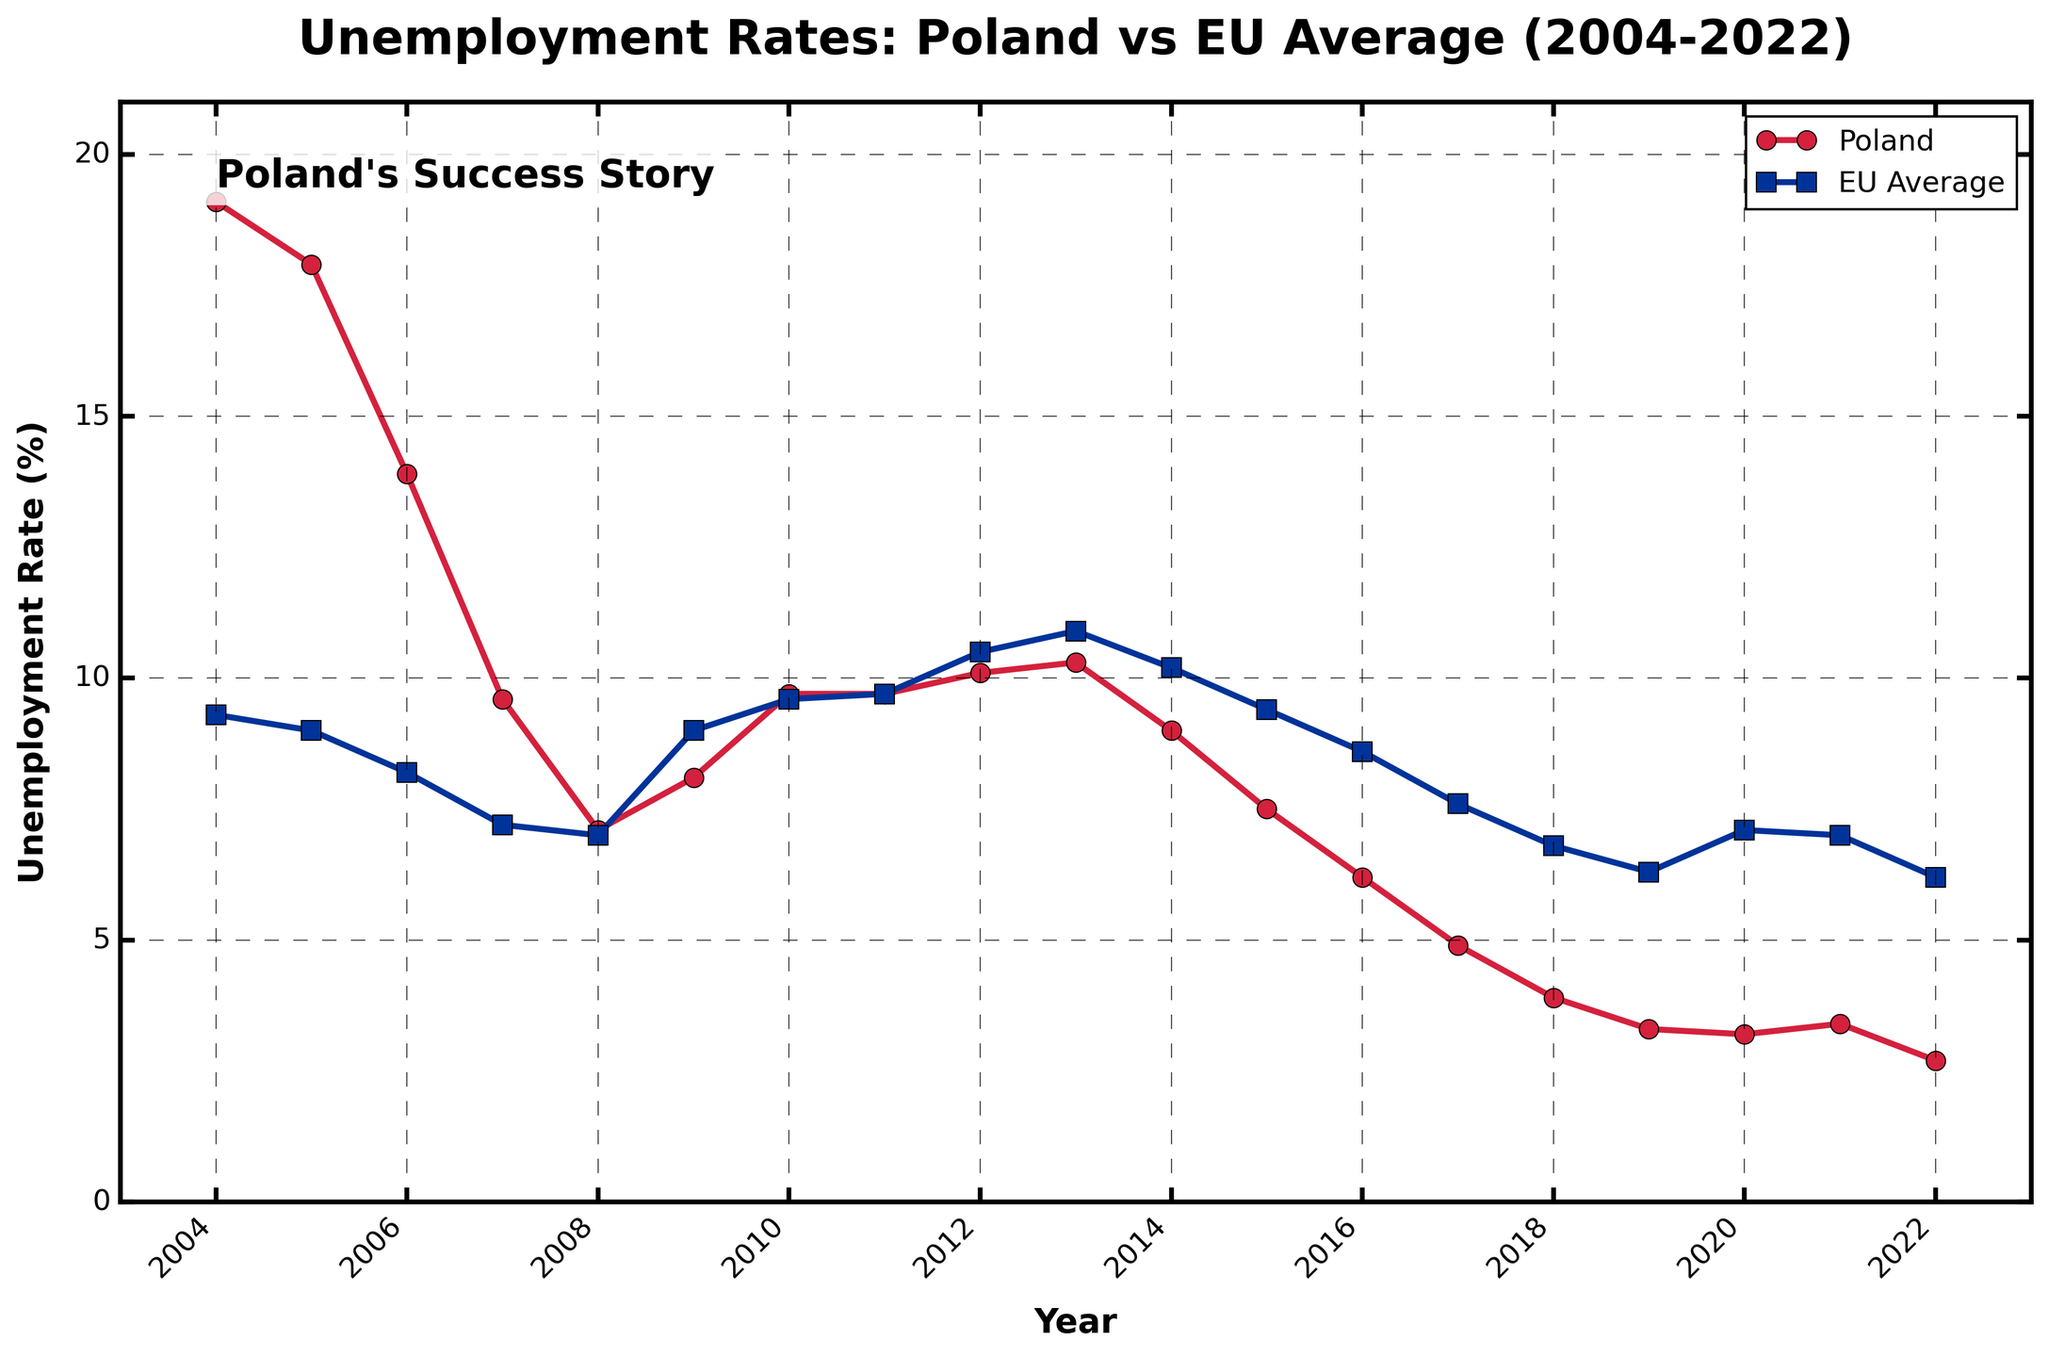What were the highest and lowest unemployment rates in Poland from 2004 to 2022? The highest unemployment rate in Poland occurred in 2004 at 19.1%, and the lowest rate was in 2022 at 2.7%. These can be identified by observing the peaks and troughs on the Poland line in the chart.
Answer: Highest: 19.1%, Lowest: 2.7% Between which years did Poland's unemployment rate fall below the EU average for the first time? The Poland unemployment rate first fell below the EU average between 2008 and 2009 when Poland's rate was 7.1% and the EU rate was 7.0%. By 2009, Poland's rate increased slightly but was more than the EU average again.
Answer: 2008 How did the unemployment rate in Poland change from 2004 to 2008, and how did it compare to the EU average in 2008? In 2004, Poland had an unemployment rate of 19.1%, which rapidly decreased to 7.1% by 2008. The EU average, on the other hand, decreased slightly from 9.3% to 7.0%. So, in 2008, Poland was just higher than the EU average.
Answer: Decreased to 7.1%; EU average at 7.0% Which year had the largest gap between the Poland unemployment rate and the EU average, and what was the gap? The largest gap occurred in 2004, with Poland at 19.1% and the EU average at 9.3%. This results in a gap of 19.1% - 9.3% = 9.8%.
Answer: 2004, 9.8% Between 2012 and 2017, did Poland's unemployment rate ever exceed the EU average? No, Poland's unemployment rate did not exceed the EU average between 2012 and 2017. During this period, Poland's rate consistently stayed lower than the EU average.
Answer: No From 2011 to 2013, how did the trend of unemployment rates compare between Poland and the EU average? Between 2011 and 2013, Poland’s unemployment rate increased from 9.7% to 10.3%. The EU average also increased from 9.7% to 10.9%. Thus, both showed an increasing trend during this period.
Answer: Both increased What can be inferred about the trends in Poland’s unemployment rate after it joined the EU compared to the EU average? After joining the EU, Poland's unemployment rate showed a generally steep downward trend, especially between 2004 to 2008, and consistently fell below the EU average after 2013. The EU average fluctuated but declined more moderately.
Answer: Poland decreased steeply, EU average fluctuated In which year did Poland have the lowest unemployment rate, and how did it compare to the EU average in the same year? Poland's lowest unemployment rate was in 2022 at 2.7%, while the EU average in that same year was 6.2%.
Answer: 2022, 2.7% vs. 6.2% Which color represents Poland's unemployment rate on the chart? The color red represents Poland's unemployment rate on the chart, as indicated by the legend.
Answer: Red 